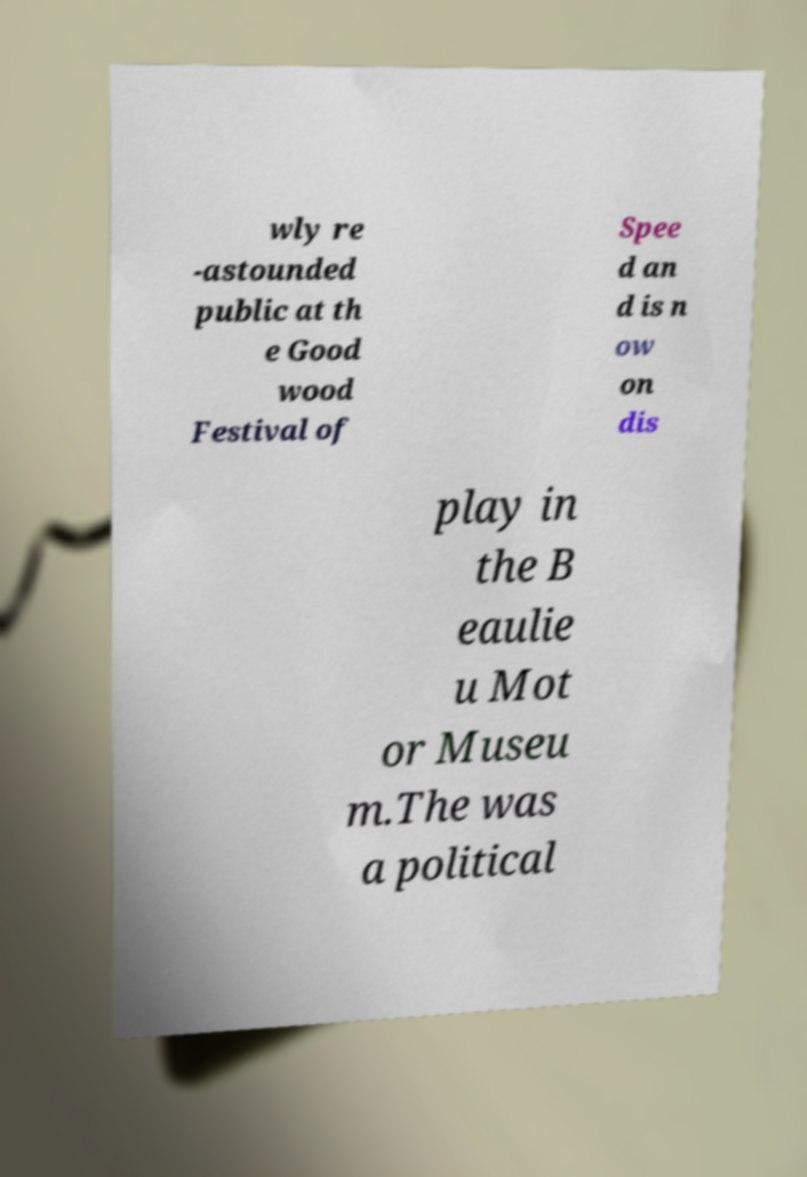There's text embedded in this image that I need extracted. Can you transcribe it verbatim? wly re -astounded public at th e Good wood Festival of Spee d an d is n ow on dis play in the B eaulie u Mot or Museu m.The was a political 